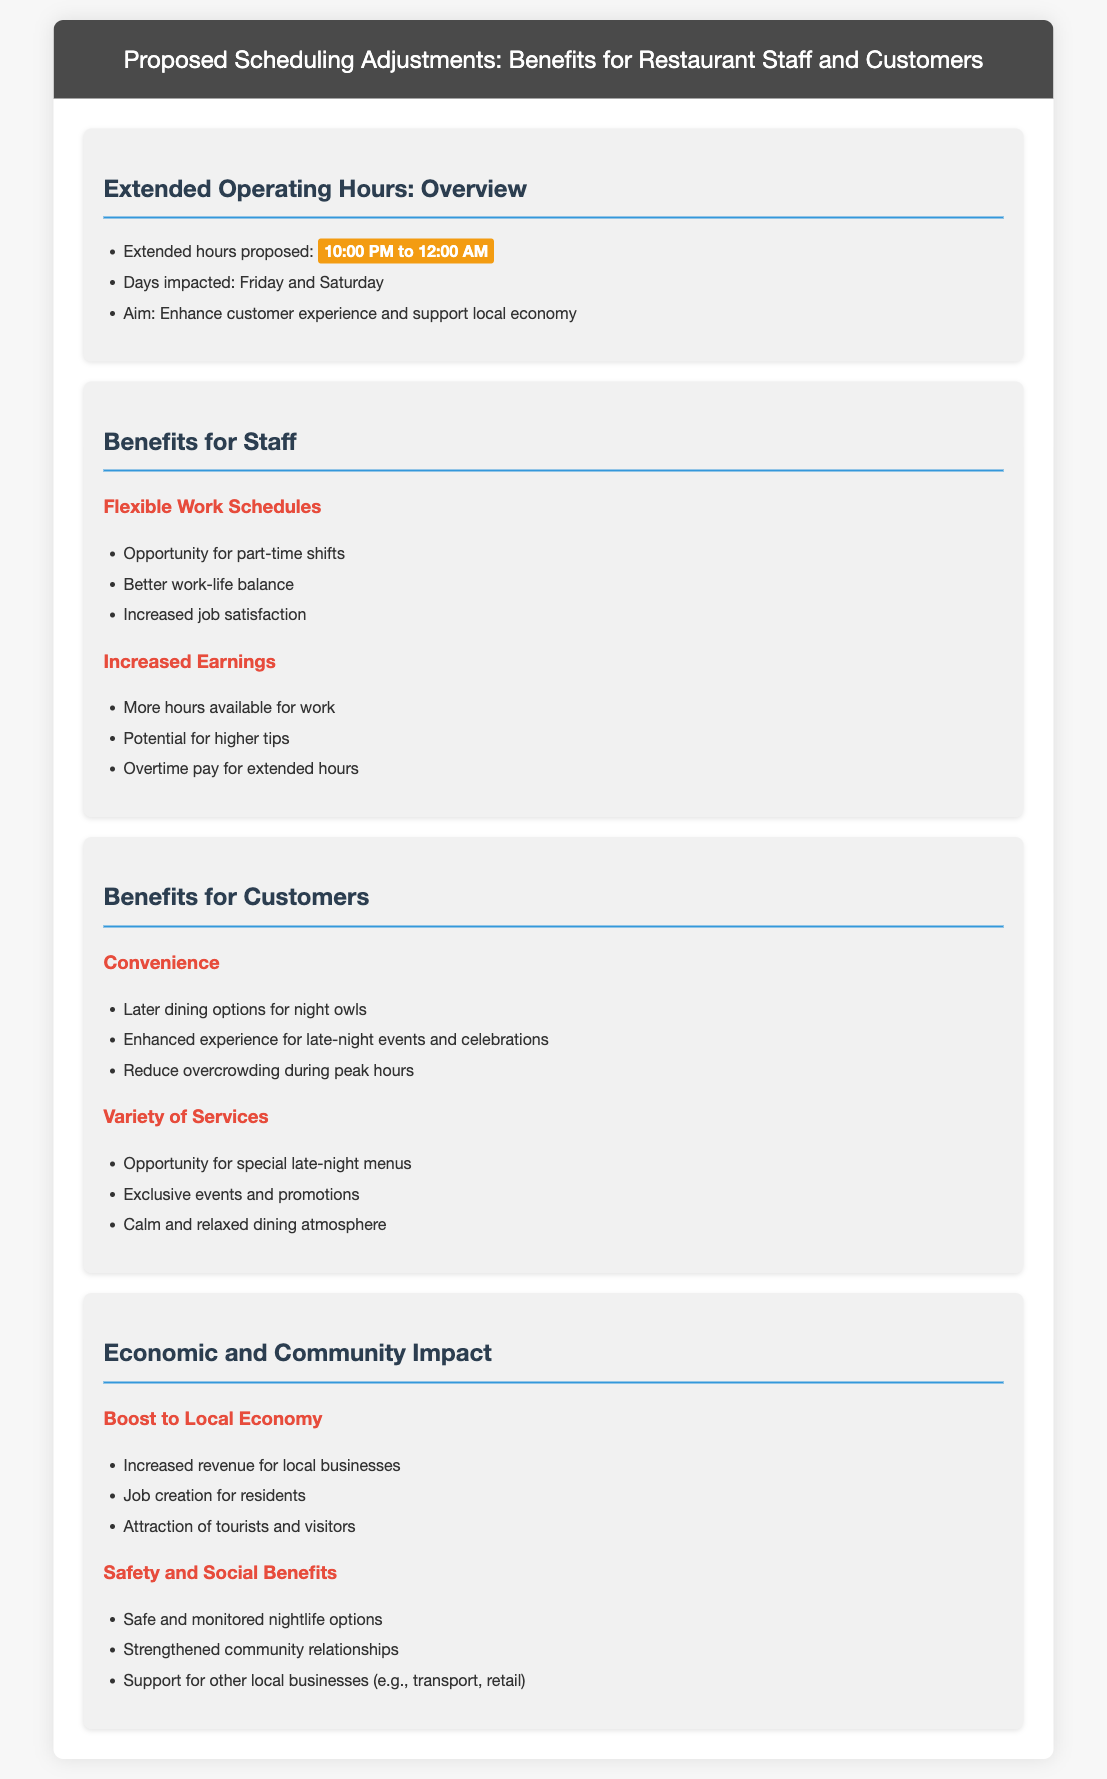what are the proposed extended hours? The proposed extended hours are specified in the Overview section of the document.
Answer: 10:00 PM to 12:00 AM which days are impacted by the proposed changes? The impacted days can be found in the Overview section of the document.
Answer: Friday and Saturday what is one benefit of extended hours for staff? This information can be found in the Benefits for Staff section, particularly under Flexible Work Schedules.
Answer: Better work-life balance how can customers benefit from late dining options? Customer benefits are detailed in the Benefits for Customers section, specifically in the Convenience area.
Answer: Later dining options for night owls what is one economic impact of extended hours? The Economic and Community Impact section outlines the benefits, including a specific example.
Answer: Increased revenue for local businesses how do extended hours enhance customer experience during celebrations? This can be inferred from the Benefits for Customers section, particularly in the Convenience area.
Answer: Enhanced experience for late-night events and celebrations what is an example of a special service offered during extended hours? The Benefits for Customers section discusses special services, especially under Variety of Services.
Answer: Opportunity for special late-night menus what does extending operating hours aim to support? The aim is stated clearly in the Overview section of the document.
Answer: Support local economy 